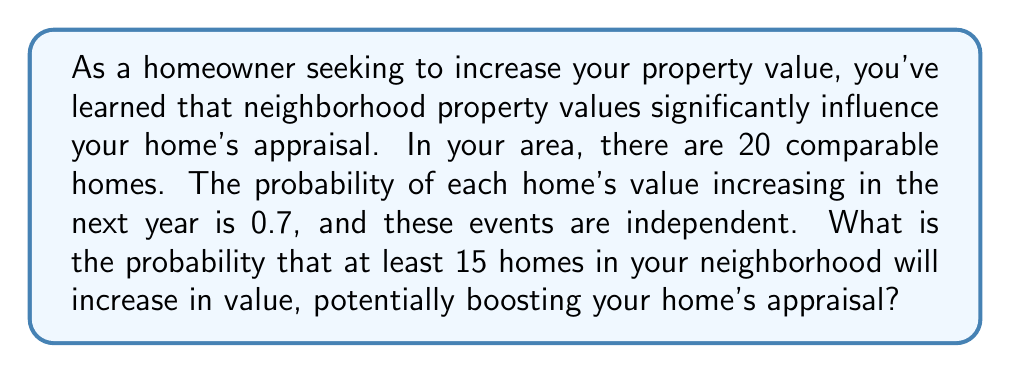Teach me how to tackle this problem. To solve this problem, we'll use the binomial probability distribution, as we're dealing with a fixed number of independent trials (20 homes) with a constant probability of success (0.7 for each home increasing in value).

Let $X$ be the number of homes that increase in value. We want to find $P(X \geq 15)$.

The probability mass function for a binomial distribution is:

$$P(X = k) = \binom{n}{k} p^k (1-p)^{n-k}$$

Where:
$n$ = total number of trials (20 homes)
$k$ = number of successes
$p$ = probability of success for each trial (0.7)

We need to calculate:

$$P(X \geq 15) = P(X = 15) + P(X = 16) + P(X = 17) + P(X = 18) + P(X = 19) + P(X = 20)$$

Let's calculate each term:

$$P(X = 15) = \binom{20}{15} 0.7^{15} (1-0.7)^{5} = 0.1460$$
$$P(X = 16) = \binom{20}{16} 0.7^{16} (1-0.7)^{4} = 0.1753$$
$$P(X = 17) = \binom{20}{17} 0.7^{17} (1-0.7)^{3} = 0.1753$$
$$P(X = 18) = \binom{20}{18} 0.7^{18} (1-0.7)^{2} = 0.1401$$
$$P(X = 19) = \binom{20}{19} 0.7^{19} (1-0.7)^{1} = 0.0818$$
$$P(X = 20) = \binom{20}{20} 0.7^{20} (1-0.7)^{0} = 0.0282$$

Now, we sum these probabilities:

$$P(X \geq 15) = 0.1460 + 0.1753 + 0.1753 + 0.1401 + 0.0818 + 0.0282 = 0.7467$$
Answer: The probability that at least 15 homes in your neighborhood will increase in value is approximately 0.7467 or 74.67%. 